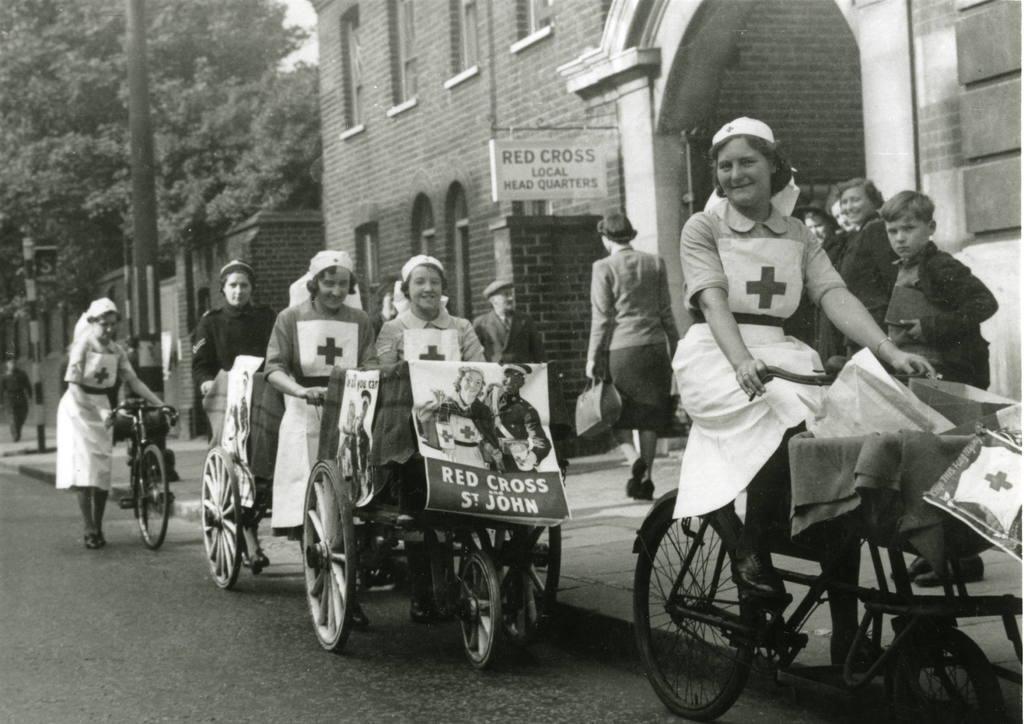How would you summarize this image in a sentence or two? In the picture we can see a road on it we can see two wheel chairs and on it we can see nurses sitting and in front of them we can see one woman is riding a bicycle and beside them we can see a path on it we can see some people are standing and smiling and beside them we can see a building and a name to it as red cross local head quarters and beside the building we can see some houses, poles and trees. 